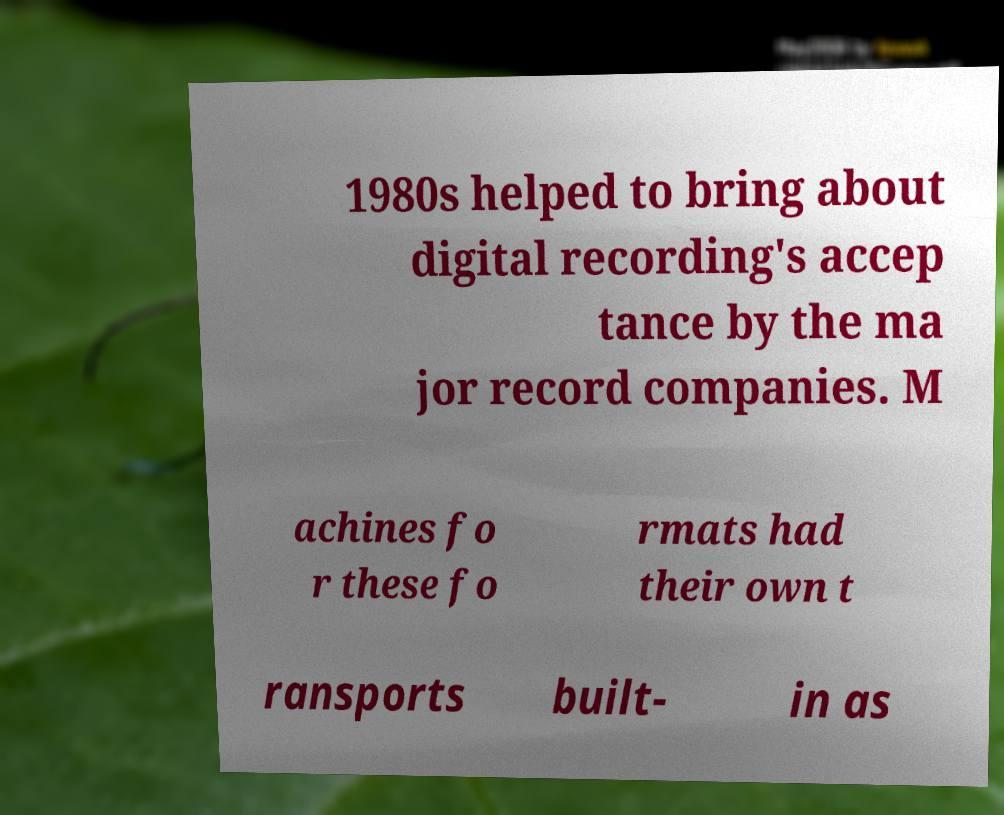Please read and relay the text visible in this image. What does it say? 1980s helped to bring about digital recording's accep tance by the ma jor record companies. M achines fo r these fo rmats had their own t ransports built- in as 